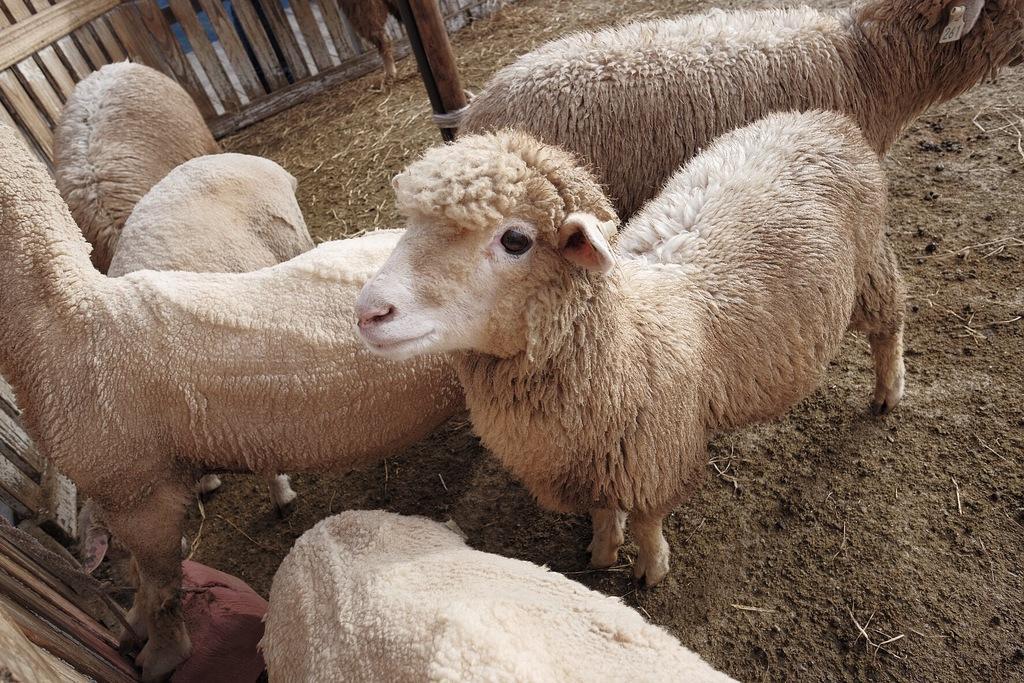Can you describe this image briefly? In the foreground of this image, there are six sheep on the ground. In the background, there is a pole and the railing. 